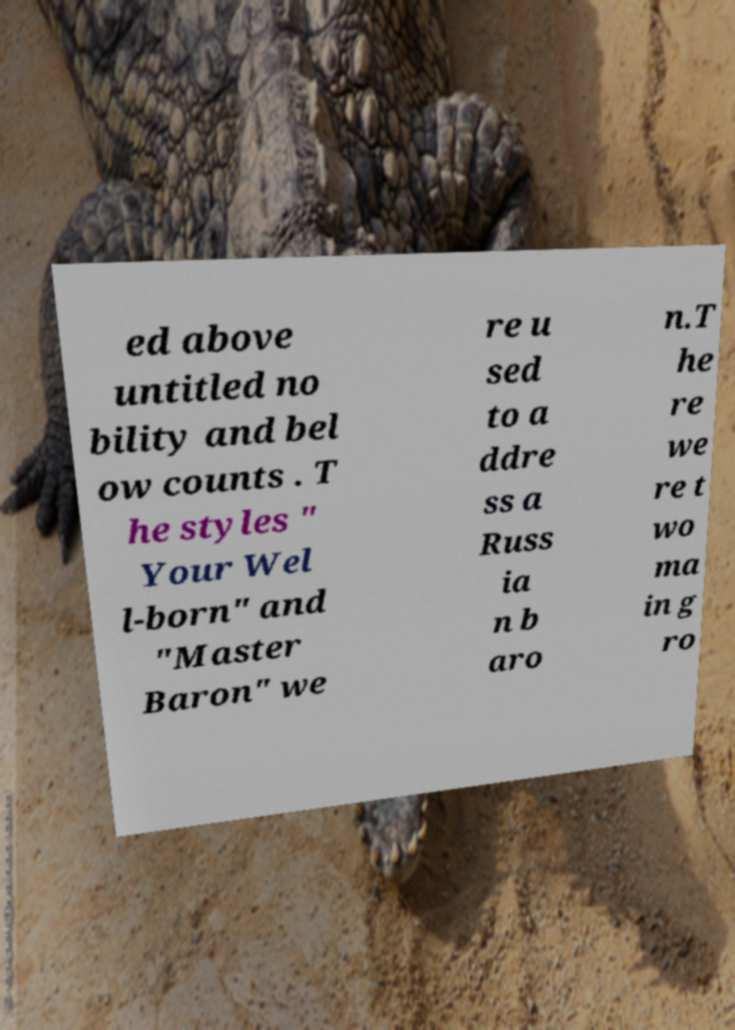What messages or text are displayed in this image? I need them in a readable, typed format. ed above untitled no bility and bel ow counts . T he styles " Your Wel l-born" and "Master Baron" we re u sed to a ddre ss a Russ ia n b aro n.T he re we re t wo ma in g ro 